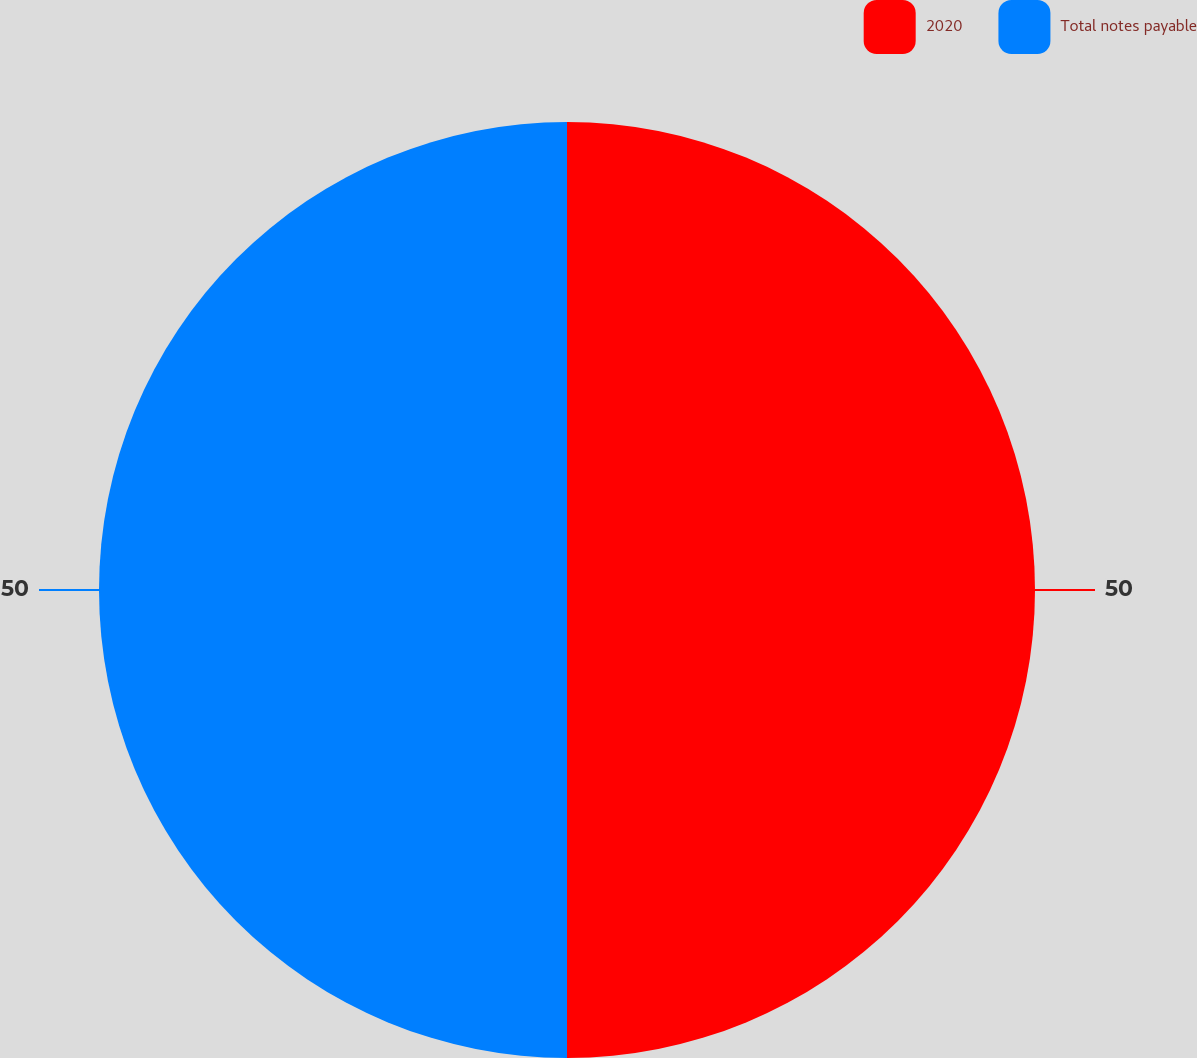<chart> <loc_0><loc_0><loc_500><loc_500><pie_chart><fcel>2020<fcel>Total notes payable<nl><fcel>50.0%<fcel>50.0%<nl></chart> 